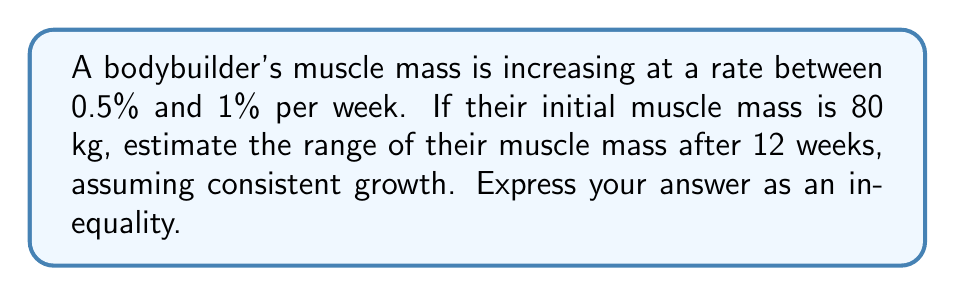Give your solution to this math problem. Let's approach this step-by-step:

1) We need to calculate the muscle mass after 12 weeks for both the lower (0.5%) and upper (1%) growth rates.

2) For the lower bound (0.5% growth per week):
   $$ M_{\text{lower}} = 80 \cdot (1 + 0.005)^{12} $$

3) For the upper bound (1% growth per week):
   $$ M_{\text{upper}} = 80 \cdot (1 + 0.01)^{12} $$

4) Let's calculate these values:
   $$ M_{\text{lower}} = 80 \cdot (1.005)^{12} \approx 84.89 \text{ kg} $$
   $$ M_{\text{upper}} = 80 \cdot (1.01)^{12} \approx 90.12 \text{ kg} $$

5) Therefore, after 12 weeks, the bodybuilder's muscle mass will be between these two values.

6) We can express this as an inequality:
   $$ 84.89 < M < 90.12 $$

   Where $M$ represents the bodybuilder's muscle mass after 12 weeks.
Answer: $$ 84.89 < M < 90.12 $$
Where $M$ is the bodybuilder's muscle mass in kg after 12 weeks. 